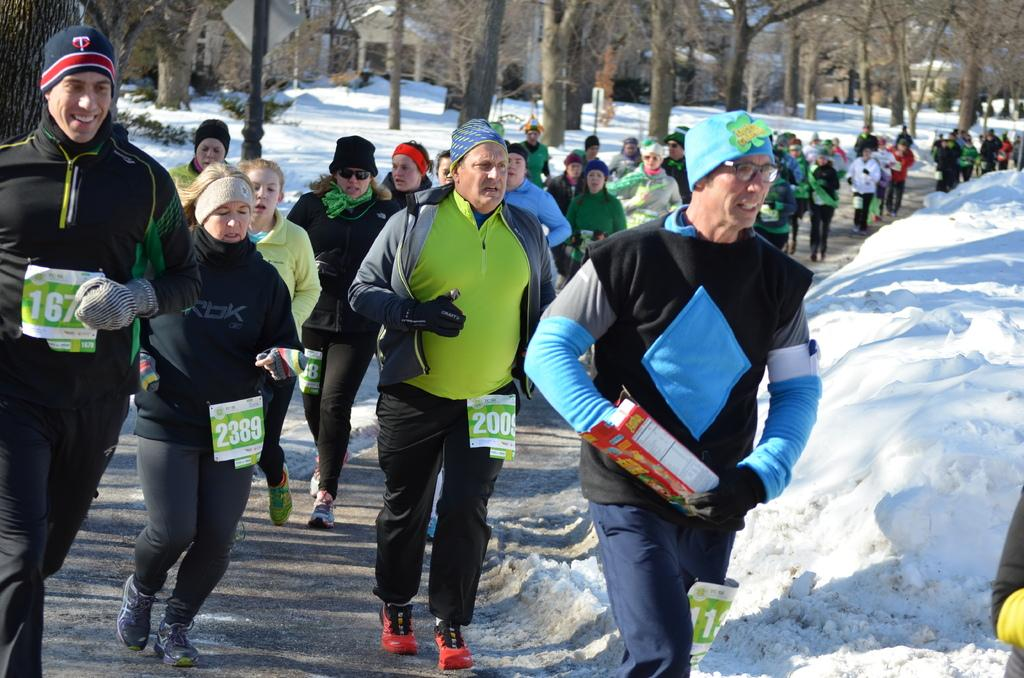What type of vegetation can be seen in the image? There are trees in the image. What is the weather like in the image? There is snow in the image, indicating a cold and likely wintery scene. What type of structures are visible in the image? There are houses in the image. What are the people in the image doing? There are people running on the road in the image. What object is being held by a person in the image? There is a person holding a box in the image. Can you tell me how many beginner skiers are visible in the image? There is no information about skiers, let alone their skill level, in the image. What type of smile can be seen on the person holding the box? There is no indication of a smile or any facial expression on the person holding the box in the image. 